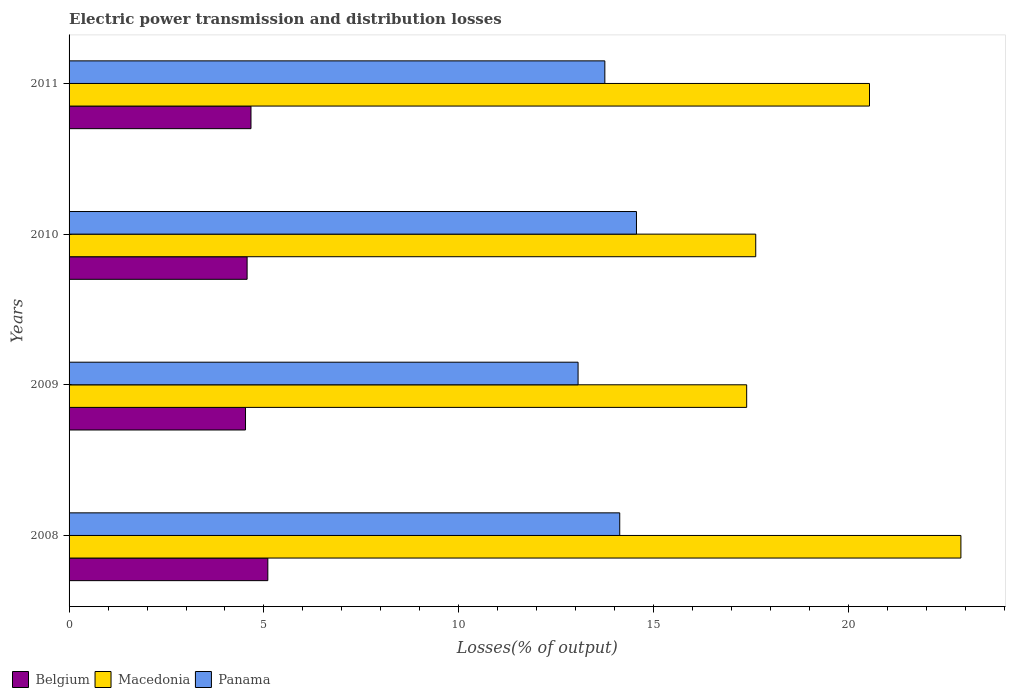Are the number of bars on each tick of the Y-axis equal?
Give a very brief answer. Yes. How many bars are there on the 1st tick from the top?
Ensure brevity in your answer.  3. How many bars are there on the 1st tick from the bottom?
Keep it short and to the point. 3. What is the electric power transmission and distribution losses in Macedonia in 2009?
Provide a short and direct response. 17.38. Across all years, what is the maximum electric power transmission and distribution losses in Macedonia?
Your response must be concise. 22.88. Across all years, what is the minimum electric power transmission and distribution losses in Panama?
Your response must be concise. 13.06. In which year was the electric power transmission and distribution losses in Panama maximum?
Make the answer very short. 2010. In which year was the electric power transmission and distribution losses in Macedonia minimum?
Offer a very short reply. 2009. What is the total electric power transmission and distribution losses in Belgium in the graph?
Ensure brevity in your answer.  18.86. What is the difference between the electric power transmission and distribution losses in Macedonia in 2008 and that in 2011?
Your answer should be compact. 2.35. What is the difference between the electric power transmission and distribution losses in Belgium in 2011 and the electric power transmission and distribution losses in Panama in 2008?
Your answer should be compact. -9.46. What is the average electric power transmission and distribution losses in Macedonia per year?
Make the answer very short. 19.6. In the year 2008, what is the difference between the electric power transmission and distribution losses in Belgium and electric power transmission and distribution losses in Panama?
Offer a very short reply. -9.03. In how many years, is the electric power transmission and distribution losses in Belgium greater than 7 %?
Keep it short and to the point. 0. What is the ratio of the electric power transmission and distribution losses in Panama in 2008 to that in 2011?
Offer a terse response. 1.03. Is the electric power transmission and distribution losses in Belgium in 2008 less than that in 2011?
Your answer should be very brief. No. Is the difference between the electric power transmission and distribution losses in Belgium in 2010 and 2011 greater than the difference between the electric power transmission and distribution losses in Panama in 2010 and 2011?
Keep it short and to the point. No. What is the difference between the highest and the second highest electric power transmission and distribution losses in Belgium?
Offer a terse response. 0.43. What is the difference between the highest and the lowest electric power transmission and distribution losses in Panama?
Make the answer very short. 1.5. Are all the bars in the graph horizontal?
Make the answer very short. Yes. How many years are there in the graph?
Ensure brevity in your answer.  4. Where does the legend appear in the graph?
Offer a terse response. Bottom left. How many legend labels are there?
Your answer should be very brief. 3. What is the title of the graph?
Keep it short and to the point. Electric power transmission and distribution losses. What is the label or title of the X-axis?
Keep it short and to the point. Losses(% of output). What is the label or title of the Y-axis?
Your answer should be very brief. Years. What is the Losses(% of output) of Belgium in 2008?
Ensure brevity in your answer.  5.1. What is the Losses(% of output) in Macedonia in 2008?
Your response must be concise. 22.88. What is the Losses(% of output) of Panama in 2008?
Keep it short and to the point. 14.13. What is the Losses(% of output) of Belgium in 2009?
Provide a short and direct response. 4.53. What is the Losses(% of output) of Macedonia in 2009?
Your response must be concise. 17.38. What is the Losses(% of output) in Panama in 2009?
Make the answer very short. 13.06. What is the Losses(% of output) of Belgium in 2010?
Provide a succinct answer. 4.57. What is the Losses(% of output) in Macedonia in 2010?
Your response must be concise. 17.62. What is the Losses(% of output) of Panama in 2010?
Provide a short and direct response. 14.56. What is the Losses(% of output) of Belgium in 2011?
Offer a very short reply. 4.67. What is the Losses(% of output) of Macedonia in 2011?
Make the answer very short. 20.54. What is the Losses(% of output) in Panama in 2011?
Your answer should be very brief. 13.75. Across all years, what is the maximum Losses(% of output) of Belgium?
Provide a succinct answer. 5.1. Across all years, what is the maximum Losses(% of output) in Macedonia?
Your answer should be very brief. 22.88. Across all years, what is the maximum Losses(% of output) of Panama?
Your response must be concise. 14.56. Across all years, what is the minimum Losses(% of output) of Belgium?
Keep it short and to the point. 4.53. Across all years, what is the minimum Losses(% of output) of Macedonia?
Make the answer very short. 17.38. Across all years, what is the minimum Losses(% of output) in Panama?
Keep it short and to the point. 13.06. What is the total Losses(% of output) in Belgium in the graph?
Give a very brief answer. 18.86. What is the total Losses(% of output) of Macedonia in the graph?
Offer a very short reply. 78.42. What is the total Losses(% of output) in Panama in the graph?
Ensure brevity in your answer.  55.49. What is the difference between the Losses(% of output) in Belgium in 2008 and that in 2009?
Ensure brevity in your answer.  0.57. What is the difference between the Losses(% of output) in Macedonia in 2008 and that in 2009?
Give a very brief answer. 5.5. What is the difference between the Losses(% of output) in Panama in 2008 and that in 2009?
Provide a succinct answer. 1.07. What is the difference between the Losses(% of output) of Belgium in 2008 and that in 2010?
Offer a terse response. 0.53. What is the difference between the Losses(% of output) of Macedonia in 2008 and that in 2010?
Make the answer very short. 5.26. What is the difference between the Losses(% of output) in Panama in 2008 and that in 2010?
Your answer should be very brief. -0.43. What is the difference between the Losses(% of output) in Belgium in 2008 and that in 2011?
Provide a short and direct response. 0.43. What is the difference between the Losses(% of output) in Macedonia in 2008 and that in 2011?
Make the answer very short. 2.35. What is the difference between the Losses(% of output) of Panama in 2008 and that in 2011?
Offer a very short reply. 0.38. What is the difference between the Losses(% of output) in Belgium in 2009 and that in 2010?
Your answer should be compact. -0.04. What is the difference between the Losses(% of output) of Macedonia in 2009 and that in 2010?
Your answer should be compact. -0.23. What is the difference between the Losses(% of output) of Panama in 2009 and that in 2010?
Make the answer very short. -1.5. What is the difference between the Losses(% of output) of Belgium in 2009 and that in 2011?
Offer a terse response. -0.14. What is the difference between the Losses(% of output) in Macedonia in 2009 and that in 2011?
Your answer should be very brief. -3.15. What is the difference between the Losses(% of output) in Panama in 2009 and that in 2011?
Give a very brief answer. -0.69. What is the difference between the Losses(% of output) of Belgium in 2010 and that in 2011?
Offer a very short reply. -0.1. What is the difference between the Losses(% of output) of Macedonia in 2010 and that in 2011?
Make the answer very short. -2.92. What is the difference between the Losses(% of output) of Panama in 2010 and that in 2011?
Offer a very short reply. 0.81. What is the difference between the Losses(% of output) of Belgium in 2008 and the Losses(% of output) of Macedonia in 2009?
Make the answer very short. -12.29. What is the difference between the Losses(% of output) in Belgium in 2008 and the Losses(% of output) in Panama in 2009?
Your answer should be very brief. -7.96. What is the difference between the Losses(% of output) of Macedonia in 2008 and the Losses(% of output) of Panama in 2009?
Your response must be concise. 9.82. What is the difference between the Losses(% of output) of Belgium in 2008 and the Losses(% of output) of Macedonia in 2010?
Make the answer very short. -12.52. What is the difference between the Losses(% of output) of Belgium in 2008 and the Losses(% of output) of Panama in 2010?
Ensure brevity in your answer.  -9.46. What is the difference between the Losses(% of output) in Macedonia in 2008 and the Losses(% of output) in Panama in 2010?
Provide a short and direct response. 8.32. What is the difference between the Losses(% of output) in Belgium in 2008 and the Losses(% of output) in Macedonia in 2011?
Your answer should be very brief. -15.44. What is the difference between the Losses(% of output) of Belgium in 2008 and the Losses(% of output) of Panama in 2011?
Your response must be concise. -8.65. What is the difference between the Losses(% of output) of Macedonia in 2008 and the Losses(% of output) of Panama in 2011?
Make the answer very short. 9.13. What is the difference between the Losses(% of output) in Belgium in 2009 and the Losses(% of output) in Macedonia in 2010?
Provide a short and direct response. -13.09. What is the difference between the Losses(% of output) in Belgium in 2009 and the Losses(% of output) in Panama in 2010?
Make the answer very short. -10.03. What is the difference between the Losses(% of output) in Macedonia in 2009 and the Losses(% of output) in Panama in 2010?
Ensure brevity in your answer.  2.83. What is the difference between the Losses(% of output) in Belgium in 2009 and the Losses(% of output) in Macedonia in 2011?
Give a very brief answer. -16.01. What is the difference between the Losses(% of output) in Belgium in 2009 and the Losses(% of output) in Panama in 2011?
Make the answer very short. -9.22. What is the difference between the Losses(% of output) of Macedonia in 2009 and the Losses(% of output) of Panama in 2011?
Offer a terse response. 3.64. What is the difference between the Losses(% of output) in Belgium in 2010 and the Losses(% of output) in Macedonia in 2011?
Give a very brief answer. -15.97. What is the difference between the Losses(% of output) of Belgium in 2010 and the Losses(% of output) of Panama in 2011?
Give a very brief answer. -9.18. What is the difference between the Losses(% of output) in Macedonia in 2010 and the Losses(% of output) in Panama in 2011?
Give a very brief answer. 3.87. What is the average Losses(% of output) in Belgium per year?
Provide a short and direct response. 4.72. What is the average Losses(% of output) of Macedonia per year?
Provide a short and direct response. 19.6. What is the average Losses(% of output) in Panama per year?
Offer a terse response. 13.87. In the year 2008, what is the difference between the Losses(% of output) in Belgium and Losses(% of output) in Macedonia?
Ensure brevity in your answer.  -17.78. In the year 2008, what is the difference between the Losses(% of output) in Belgium and Losses(% of output) in Panama?
Provide a succinct answer. -9.03. In the year 2008, what is the difference between the Losses(% of output) in Macedonia and Losses(% of output) in Panama?
Keep it short and to the point. 8.75. In the year 2009, what is the difference between the Losses(% of output) in Belgium and Losses(% of output) in Macedonia?
Ensure brevity in your answer.  -12.86. In the year 2009, what is the difference between the Losses(% of output) in Belgium and Losses(% of output) in Panama?
Offer a terse response. -8.53. In the year 2009, what is the difference between the Losses(% of output) in Macedonia and Losses(% of output) in Panama?
Make the answer very short. 4.33. In the year 2010, what is the difference between the Losses(% of output) in Belgium and Losses(% of output) in Macedonia?
Offer a very short reply. -13.05. In the year 2010, what is the difference between the Losses(% of output) in Belgium and Losses(% of output) in Panama?
Make the answer very short. -9.99. In the year 2010, what is the difference between the Losses(% of output) of Macedonia and Losses(% of output) of Panama?
Ensure brevity in your answer.  3.06. In the year 2011, what is the difference between the Losses(% of output) of Belgium and Losses(% of output) of Macedonia?
Provide a short and direct response. -15.87. In the year 2011, what is the difference between the Losses(% of output) in Belgium and Losses(% of output) in Panama?
Offer a very short reply. -9.08. In the year 2011, what is the difference between the Losses(% of output) in Macedonia and Losses(% of output) in Panama?
Your answer should be compact. 6.79. What is the ratio of the Losses(% of output) of Belgium in 2008 to that in 2009?
Keep it short and to the point. 1.13. What is the ratio of the Losses(% of output) of Macedonia in 2008 to that in 2009?
Your answer should be very brief. 1.32. What is the ratio of the Losses(% of output) of Panama in 2008 to that in 2009?
Offer a terse response. 1.08. What is the ratio of the Losses(% of output) in Belgium in 2008 to that in 2010?
Offer a terse response. 1.12. What is the ratio of the Losses(% of output) in Macedonia in 2008 to that in 2010?
Your answer should be very brief. 1.3. What is the ratio of the Losses(% of output) of Panama in 2008 to that in 2010?
Your answer should be very brief. 0.97. What is the ratio of the Losses(% of output) in Belgium in 2008 to that in 2011?
Your answer should be very brief. 1.09. What is the ratio of the Losses(% of output) of Macedonia in 2008 to that in 2011?
Keep it short and to the point. 1.11. What is the ratio of the Losses(% of output) of Panama in 2008 to that in 2011?
Keep it short and to the point. 1.03. What is the ratio of the Losses(% of output) in Panama in 2009 to that in 2010?
Your response must be concise. 0.9. What is the ratio of the Losses(% of output) of Macedonia in 2009 to that in 2011?
Your response must be concise. 0.85. What is the ratio of the Losses(% of output) in Panama in 2009 to that in 2011?
Provide a short and direct response. 0.95. What is the ratio of the Losses(% of output) in Belgium in 2010 to that in 2011?
Give a very brief answer. 0.98. What is the ratio of the Losses(% of output) of Macedonia in 2010 to that in 2011?
Provide a succinct answer. 0.86. What is the ratio of the Losses(% of output) of Panama in 2010 to that in 2011?
Make the answer very short. 1.06. What is the difference between the highest and the second highest Losses(% of output) in Belgium?
Your response must be concise. 0.43. What is the difference between the highest and the second highest Losses(% of output) in Macedonia?
Your response must be concise. 2.35. What is the difference between the highest and the second highest Losses(% of output) in Panama?
Give a very brief answer. 0.43. What is the difference between the highest and the lowest Losses(% of output) of Belgium?
Keep it short and to the point. 0.57. What is the difference between the highest and the lowest Losses(% of output) of Macedonia?
Provide a succinct answer. 5.5. What is the difference between the highest and the lowest Losses(% of output) in Panama?
Keep it short and to the point. 1.5. 